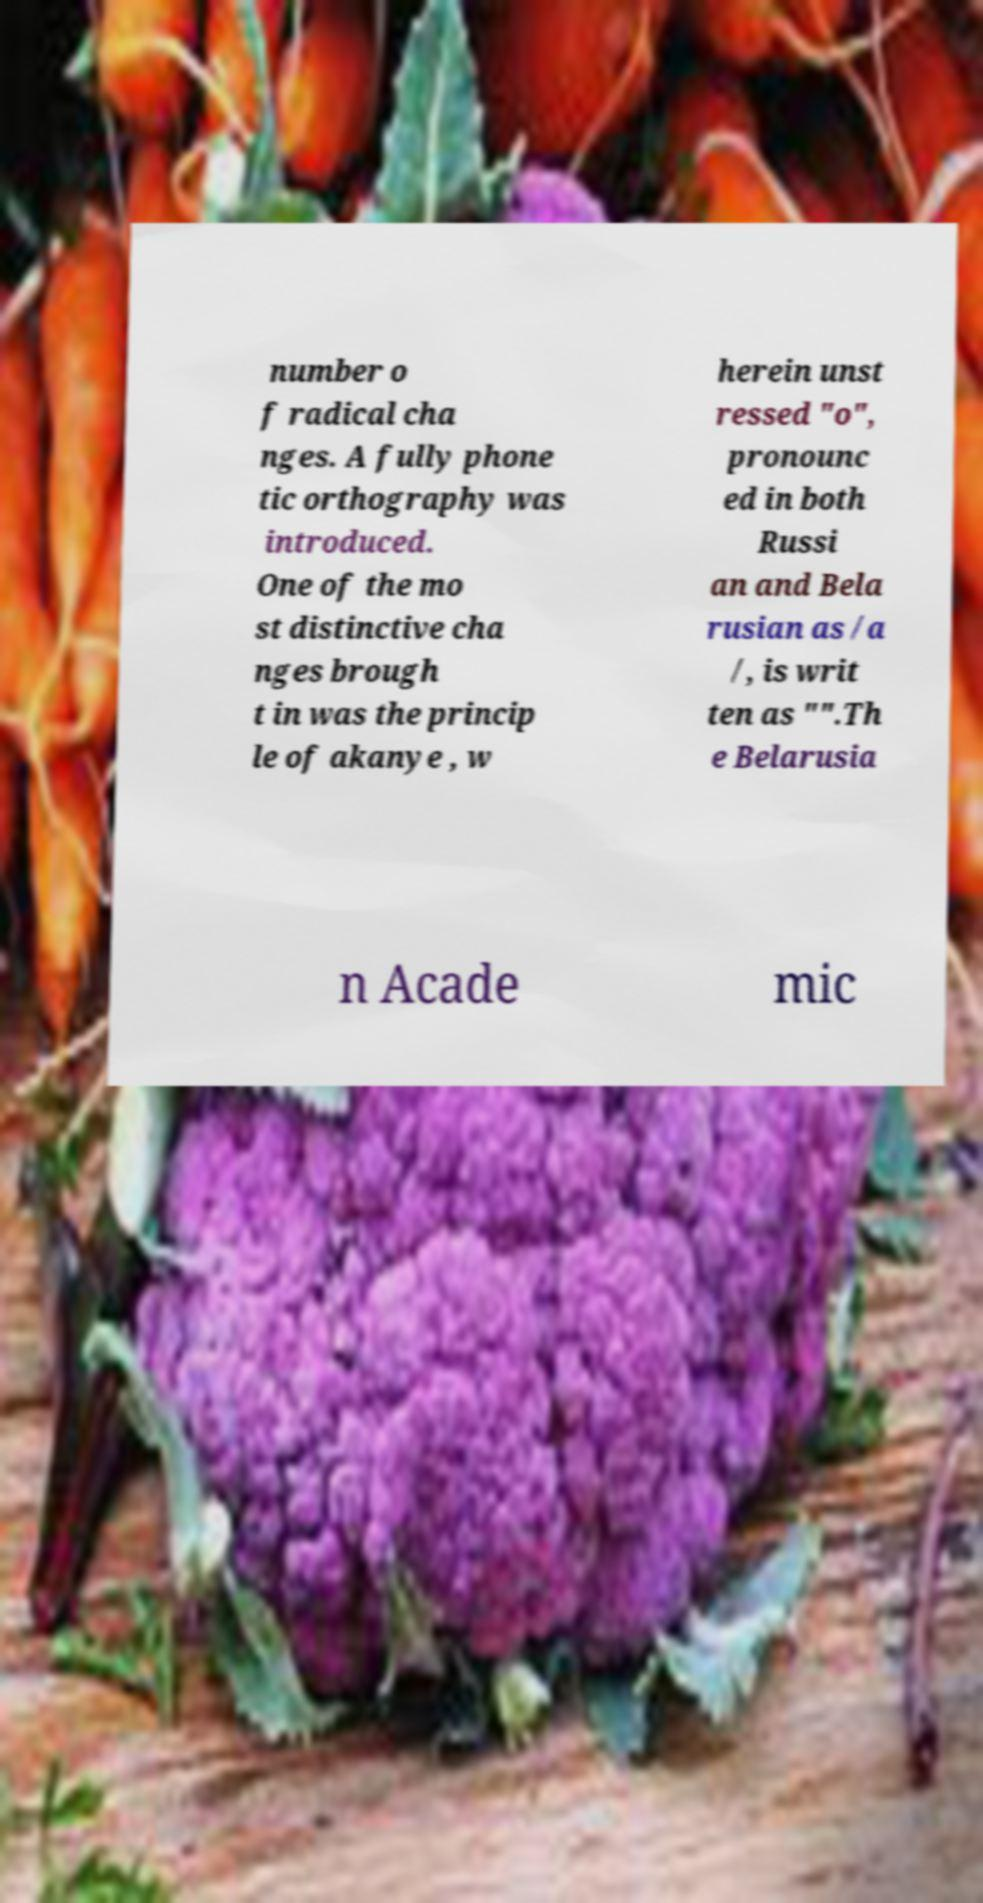There's text embedded in this image that I need extracted. Can you transcribe it verbatim? number o f radical cha nges. A fully phone tic orthography was introduced. One of the mo st distinctive cha nges brough t in was the princip le of akanye , w herein unst ressed "o", pronounc ed in both Russi an and Bela rusian as /a /, is writ ten as "".Th e Belarusia n Acade mic 